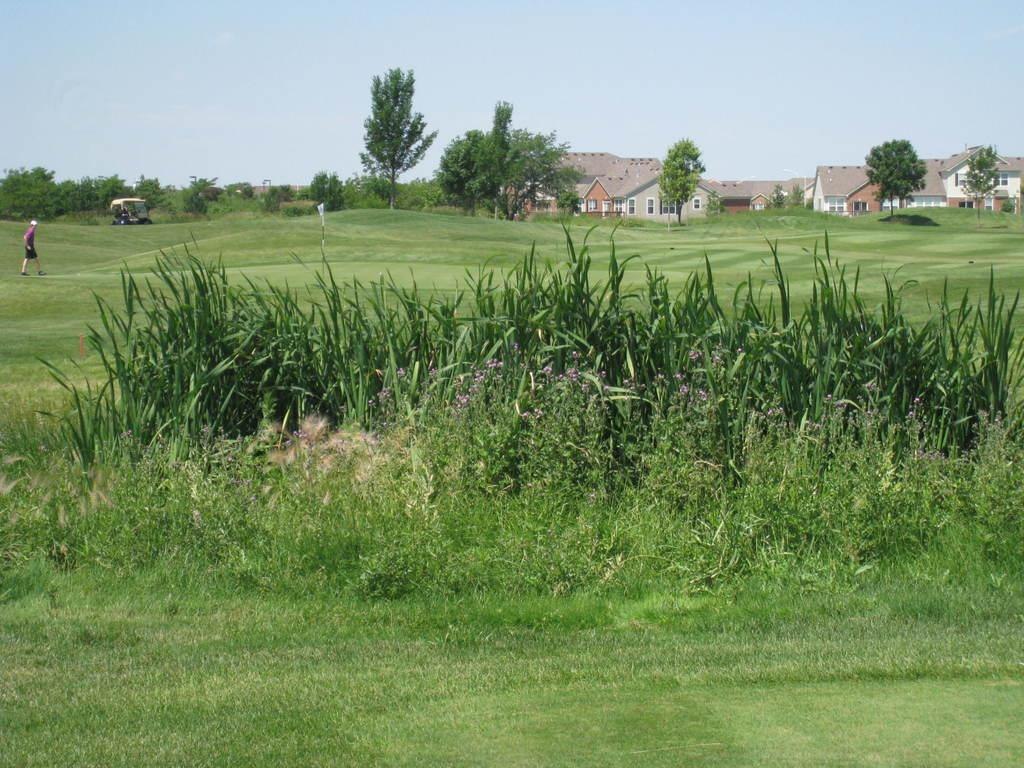What type of vegetation is present in the image? There are plants and grass in the image. What type of structures can be seen in the image? There are houses in the image. What other natural elements are visible in the image? There are trees in the image. What type of transportation is present in the image? There is a vehicle in the image. Where is the person located in the image? The person is on the left side of the image. What is visible in the background of the image? The sky is visible in the background of the image. What type of sign can be seen on the faucet in the image? There is no faucet present in the image, so it is not possible to answer that question. 